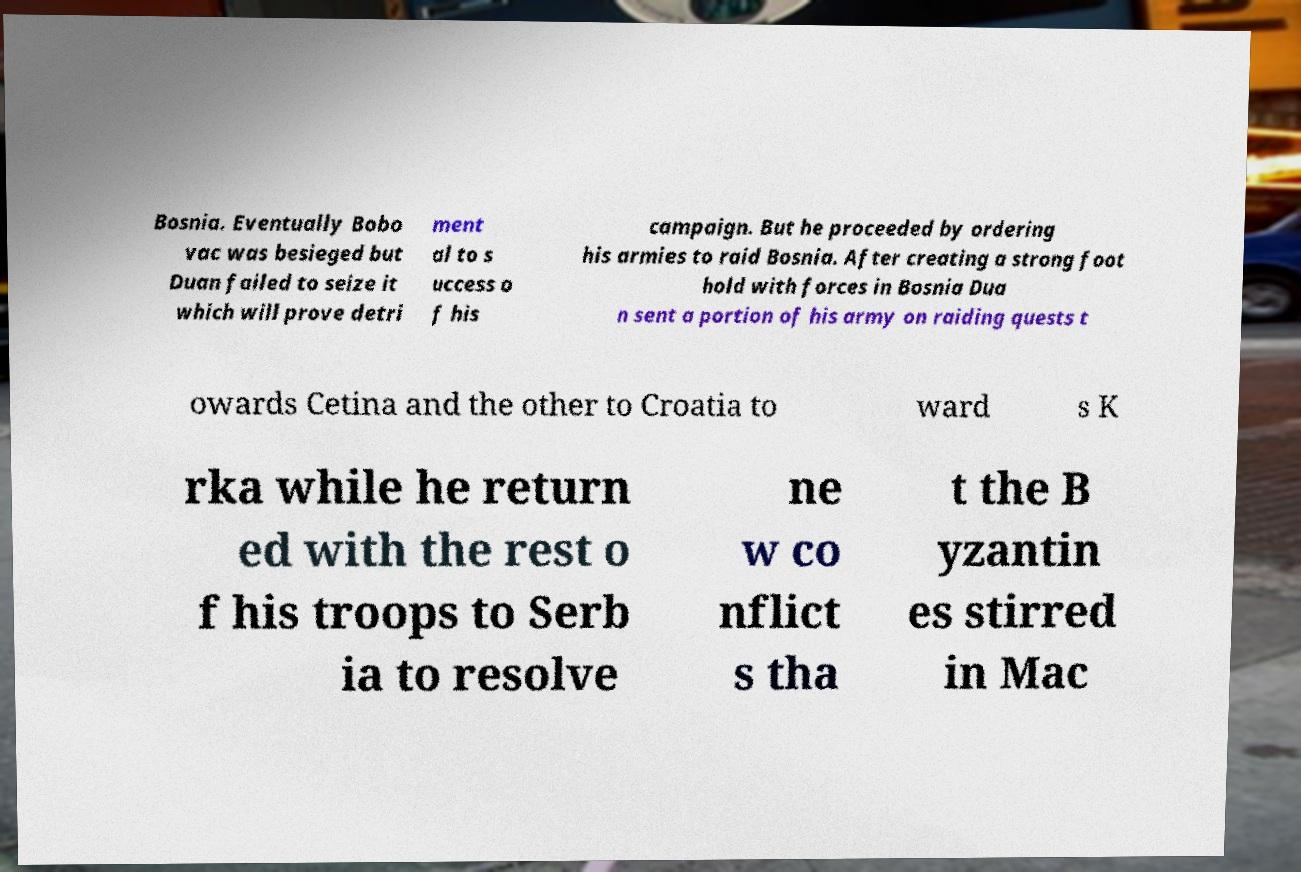Could you assist in decoding the text presented in this image and type it out clearly? Bosnia. Eventually Bobo vac was besieged but Duan failed to seize it which will prove detri ment al to s uccess o f his campaign. But he proceeded by ordering his armies to raid Bosnia. After creating a strong foot hold with forces in Bosnia Dua n sent a portion of his army on raiding quests t owards Cetina and the other to Croatia to ward s K rka while he return ed with the rest o f his troops to Serb ia to resolve ne w co nflict s tha t the B yzantin es stirred in Mac 